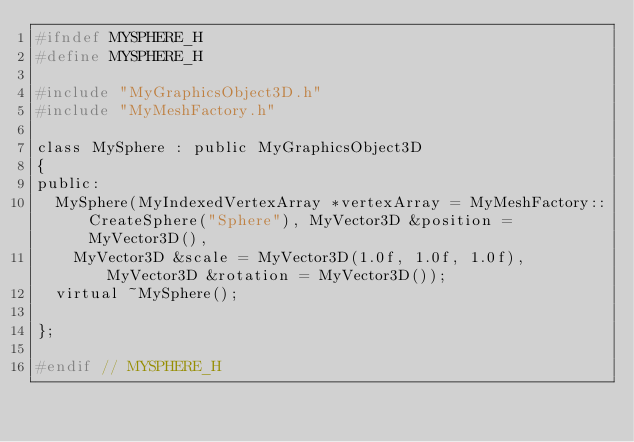<code> <loc_0><loc_0><loc_500><loc_500><_C_>#ifndef MYSPHERE_H
#define MYSPHERE_H

#include "MyGraphicsObject3D.h"
#include "MyMeshFactory.h"

class MySphere : public MyGraphicsObject3D
{
public:
	MySphere(MyIndexedVertexArray *vertexArray = MyMeshFactory::CreateSphere("Sphere"), MyVector3D &position = MyVector3D(),
		MyVector3D &scale = MyVector3D(1.0f, 1.0f, 1.0f), MyVector3D &rotation = MyVector3D());
	virtual ~MySphere();

};

#endif // MYSPHERE_H
</code> 